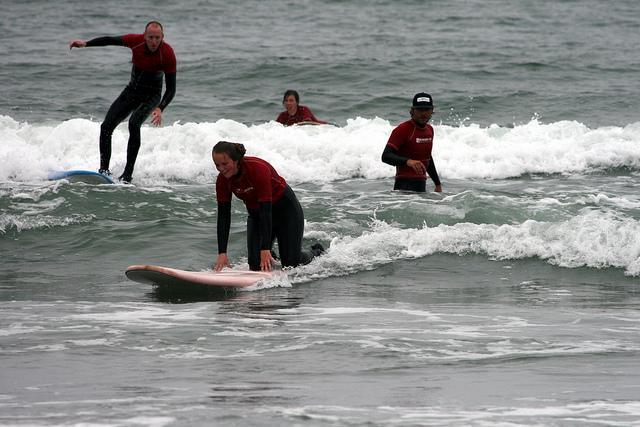What does the girl walking into the water is waiting for what to come from directly behind her so she can stand up on the board from the water waiting for what the only thing that will get her on moving on the board? Please explain your reasoning. wave. The water from the wave would push her board along so that she can balance on the board. 